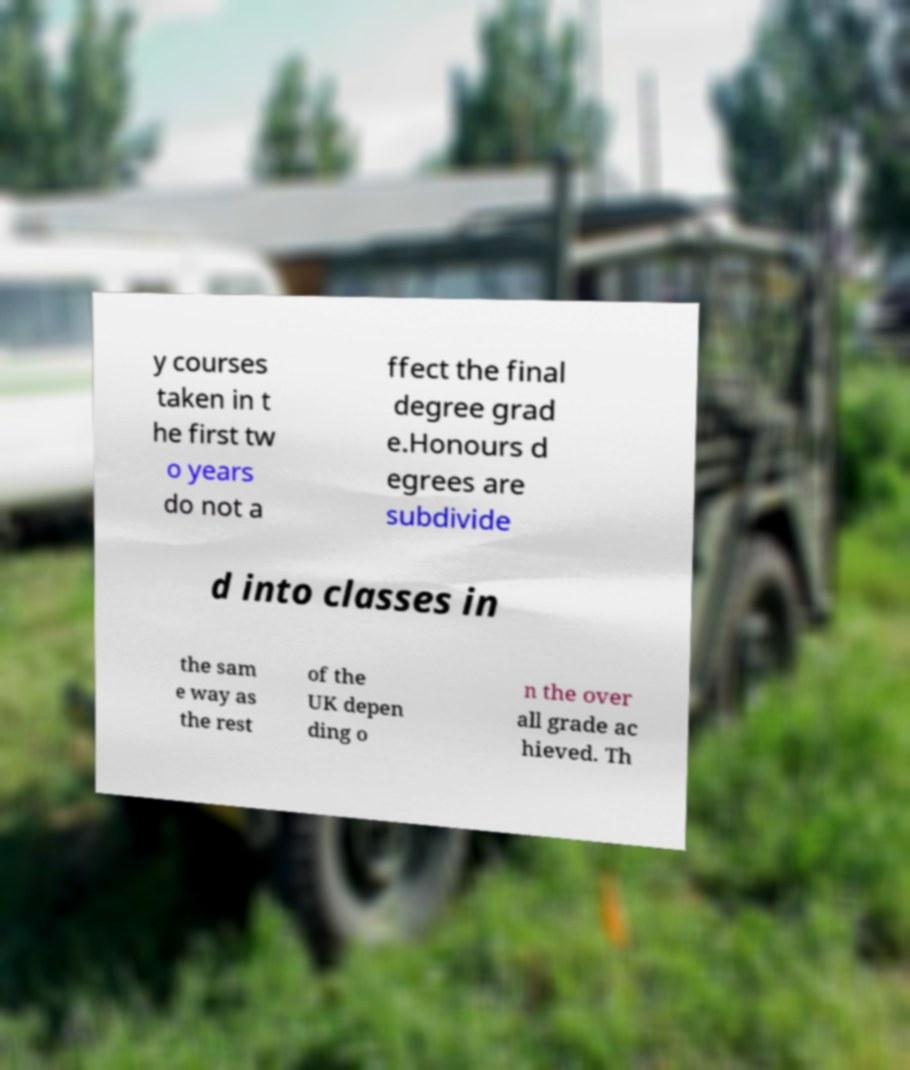Could you extract and type out the text from this image? y courses taken in t he first tw o years do not a ffect the final degree grad e.Honours d egrees are subdivide d into classes in the sam e way as the rest of the UK depen ding o n the over all grade ac hieved. Th 